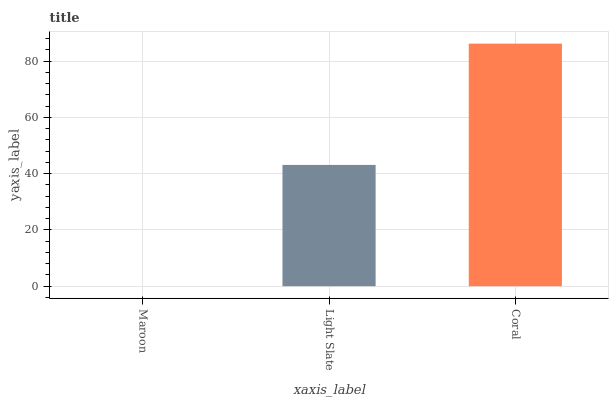Is Maroon the minimum?
Answer yes or no. Yes. Is Coral the maximum?
Answer yes or no. Yes. Is Light Slate the minimum?
Answer yes or no. No. Is Light Slate the maximum?
Answer yes or no. No. Is Light Slate greater than Maroon?
Answer yes or no. Yes. Is Maroon less than Light Slate?
Answer yes or no. Yes. Is Maroon greater than Light Slate?
Answer yes or no. No. Is Light Slate less than Maroon?
Answer yes or no. No. Is Light Slate the high median?
Answer yes or no. Yes. Is Light Slate the low median?
Answer yes or no. Yes. Is Maroon the high median?
Answer yes or no. No. Is Maroon the low median?
Answer yes or no. No. 